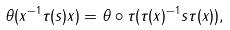Convert formula to latex. <formula><loc_0><loc_0><loc_500><loc_500>\theta ( x ^ { - 1 } \tau ( s ) x ) = \theta \circ \tau ( \tau ( x ) ^ { - 1 } s \tau ( x ) ) ,</formula> 